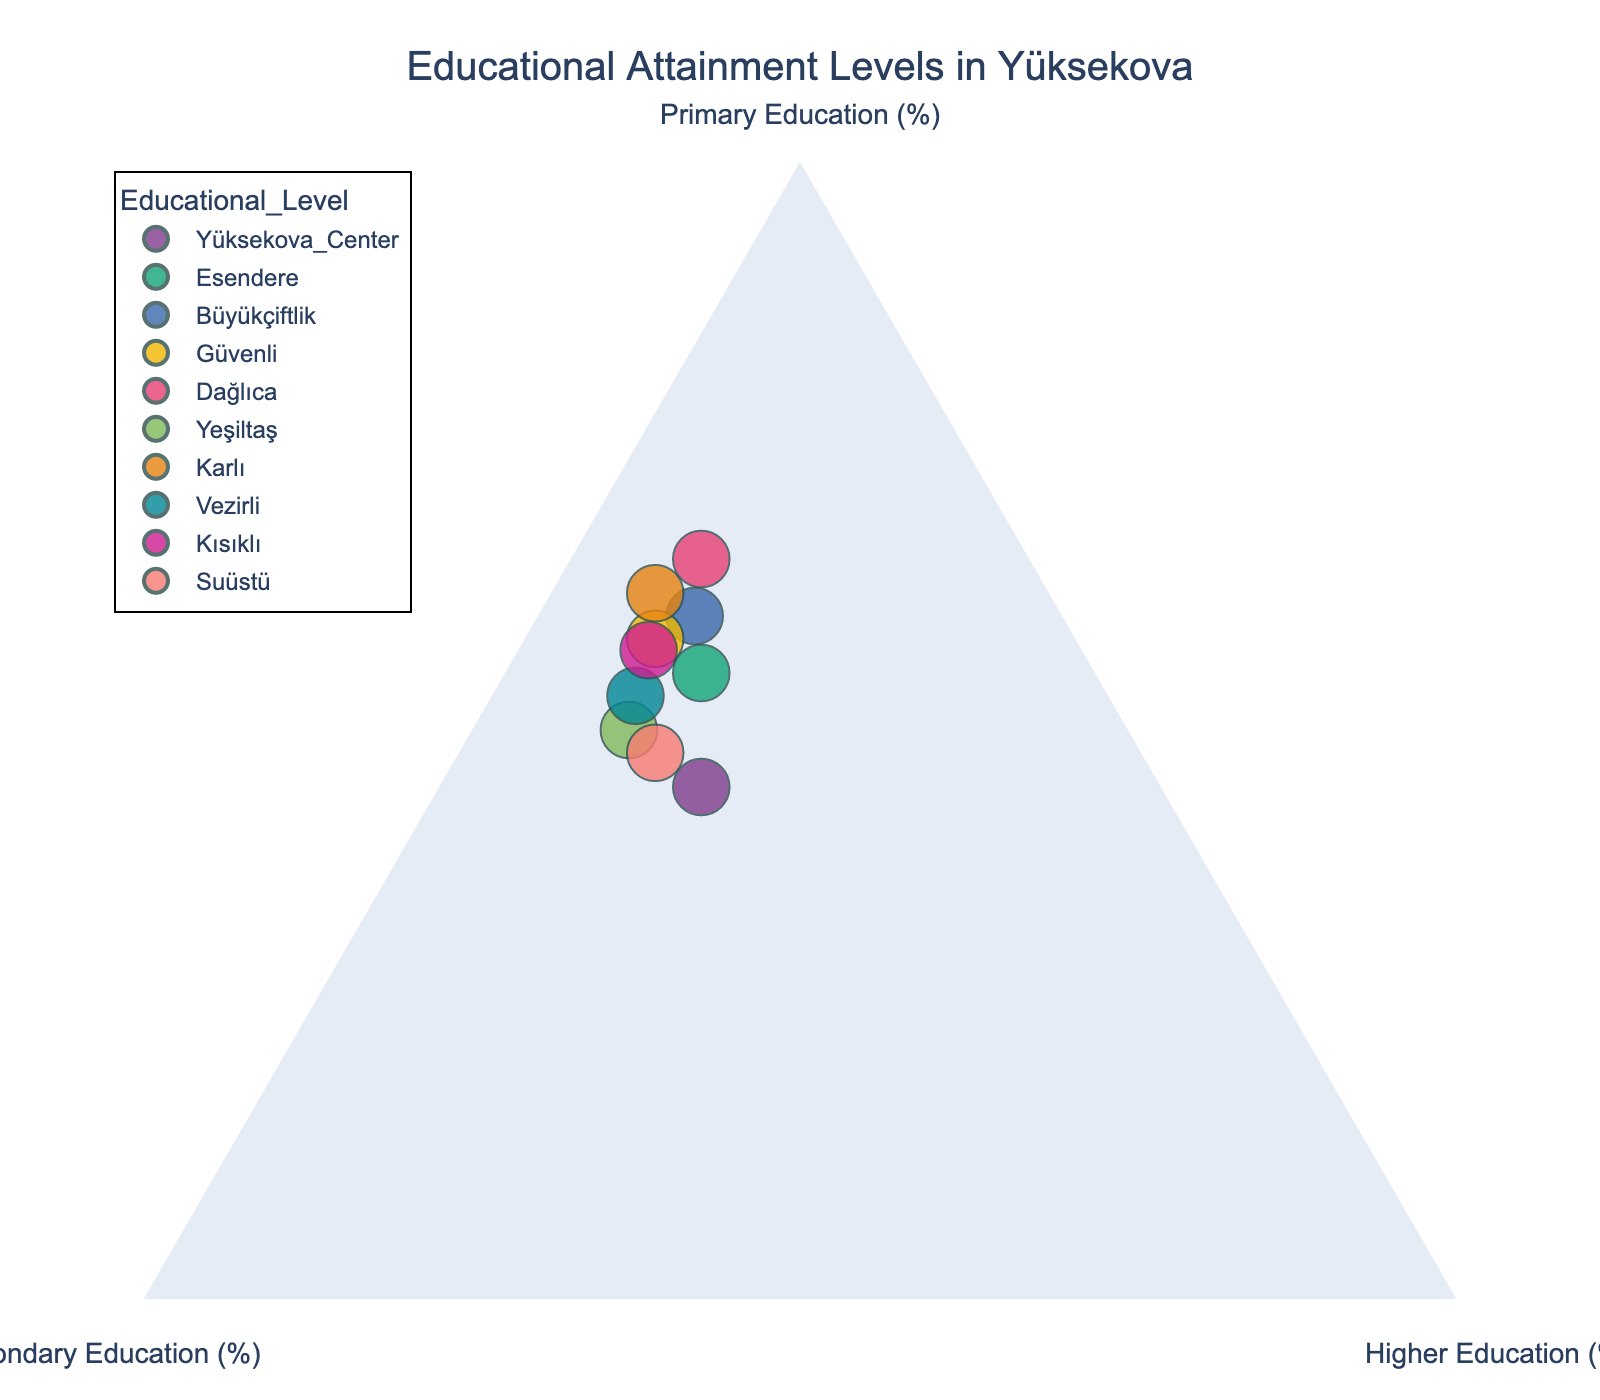What is the title of the plot? The title is displayed prominently at the top of the plot in larger, bolder font, which describes the content of the plot.
Answer: Educational Attainment Levels in Yüksekova How many data points are shown in the plot? By counting the number of distinct points or labels corresponding to locations in Yüksekova, you can determine the number of data points.
Answer: 10 Which location has the highest percentage of Primary education? By examining the position of points along the Primary Education (%) axis, you can identify the point that is furthest towards the Primary Education vertex.
Answer: Dağlıca Which location has the highest percentage of Higher education? By examining the position of points along the Higher Education (%) axis, you can identify the point that is furthest towards the Higher Education vertex.
Answer: Yüksekova Center What is the percentage of Secondary education in Esendere? By locating the Esendere data point on the plot and checking its position relative to the Secondary Education axis, you can determine this percentage.
Answer: 30% Compare the percentage of Higher education between Büyükçiftlik and Suüstü. Which one is higher? Look at the position of the points for Büyükçiftlik and Suüstü along the Higher Education (%) axis, then compare their distances from the axis.
Answer: Suüstü Which location has the most balanced distribution among the three educational levels? A balanced distribution would be closer to the center of the plot where all percentages are roughly equal. Identify the point that is closest to the center.
Answer: Yüksekova Center What is the combined percentage of Primary and Secondary education in Güvenli? Add the percentages of Primary Education and Secondary Education for Güvenli using the information provided by the plot.
Answer: 90% Is there any location where the percentage of Higher education is exactly 10%? Check the positions of all points along the Higher Education axis to find if any point aligns with the 10% tick mark.
Answer: Yes, Dağlıca and Kısıklı Which location has the lowest percentage of Secondary education, and what is that percentage? Identify the point that is furthest from the Secondary Education vertex, indicating the lowest percentage.
Answer: Dağlıca, 25% 